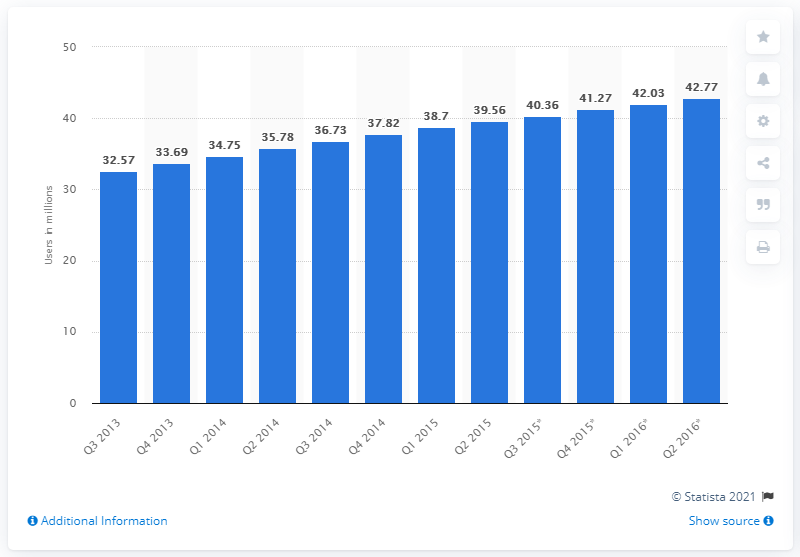Outline some significant characteristics in this image. In the UK, it is predicted that there will be 42.77 mobile internet users by quarter two of 2016. 